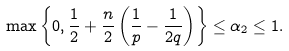Convert formula to latex. <formula><loc_0><loc_0><loc_500><loc_500>\max \left \{ 0 , \frac { 1 } { 2 } + \frac { n } { 2 } \left ( \frac { 1 } { p } - \frac { 1 } { 2 q } \right ) \right \} \leq \alpha _ { 2 } \leq 1 .</formula> 